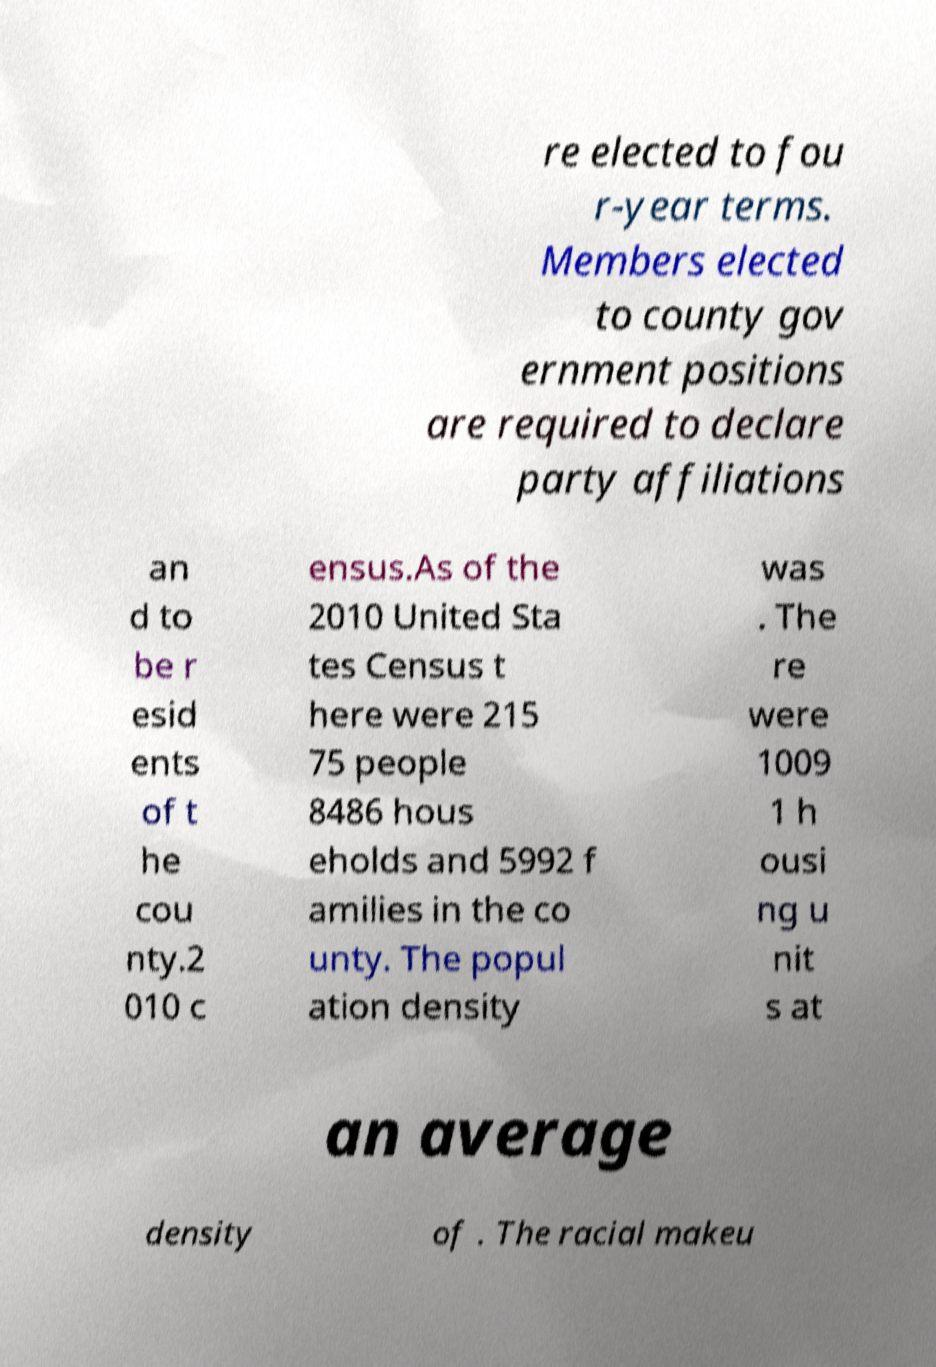There's text embedded in this image that I need extracted. Can you transcribe it verbatim? re elected to fou r-year terms. Members elected to county gov ernment positions are required to declare party affiliations an d to be r esid ents of t he cou nty.2 010 c ensus.As of the 2010 United Sta tes Census t here were 215 75 people 8486 hous eholds and 5992 f amilies in the co unty. The popul ation density was . The re were 1009 1 h ousi ng u nit s at an average density of . The racial makeu 